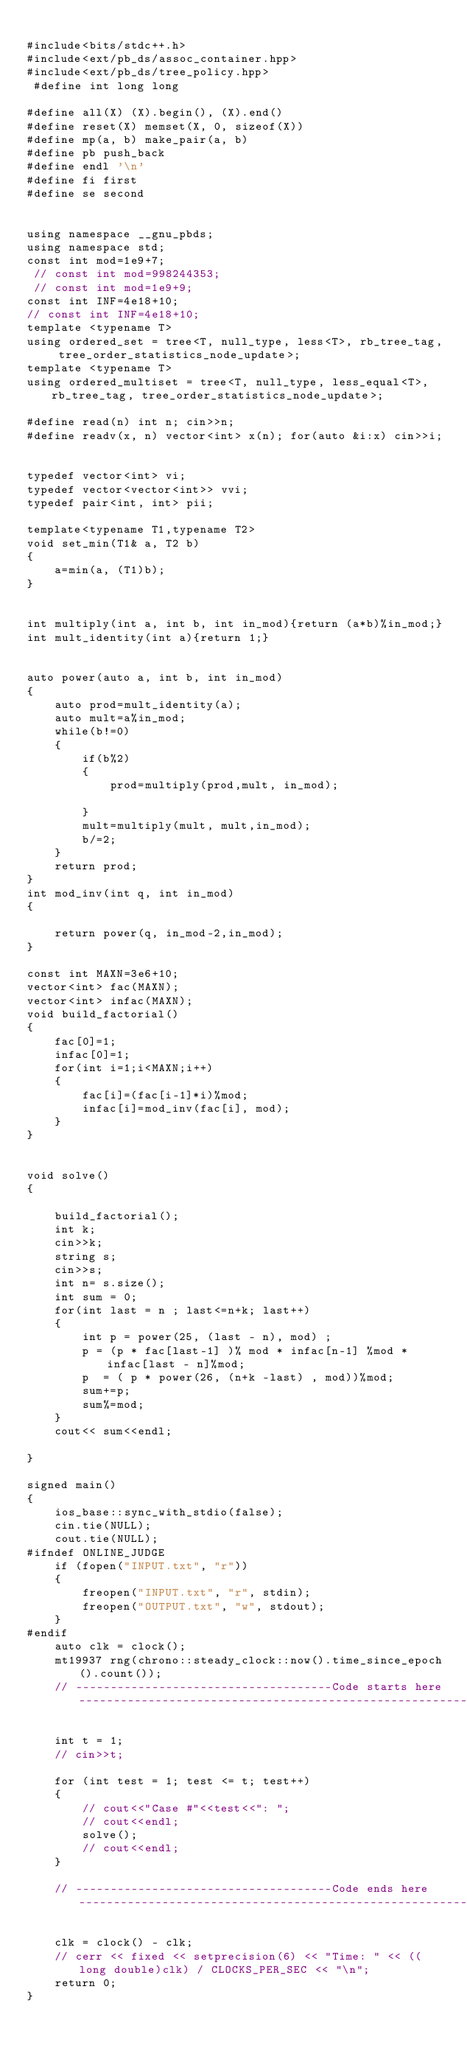Convert code to text. <code><loc_0><loc_0><loc_500><loc_500><_C++_>
#include<bits/stdc++.h>
#include<ext/pb_ds/assoc_container.hpp>
#include<ext/pb_ds/tree_policy.hpp>
 #define int long long

#define all(X) (X).begin(), (X).end()
#define reset(X) memset(X, 0, sizeof(X))
#define mp(a, b) make_pair(a, b)
#define pb push_back
#define endl '\n'
#define fi first
#define se second


using namespace __gnu_pbds;
using namespace std;
const int mod=1e9+7;
 // const int mod=998244353;
 // const int mod=1e9+9;
const int INF=4e18+10;
// const int INF=4e18+10;
template <typename T>
using ordered_set = tree<T, null_type, less<T>, rb_tree_tag, tree_order_statistics_node_update>;
template <typename T>
using ordered_multiset = tree<T, null_type, less_equal<T>, rb_tree_tag, tree_order_statistics_node_update>;

#define read(n) int n; cin>>n;
#define readv(x, n) vector<int> x(n); for(auto &i:x) cin>>i;


typedef vector<int> vi;
typedef vector<vector<int>> vvi;
typedef pair<int, int> pii;

template<typename T1,typename T2>
void set_min(T1& a, T2 b)
{
    a=min(a, (T1)b);
}


int multiply(int a, int b, int in_mod){return (a*b)%in_mod;}
int mult_identity(int a){return 1;}


auto power(auto a, int b, int in_mod)
{
    auto prod=mult_identity(a);
    auto mult=a%in_mod;
    while(b!=0)
    {
        if(b%2)
        {
            prod=multiply(prod,mult, in_mod);

        }
        mult=multiply(mult, mult,in_mod);
        b/=2;
    }
    return prod;
}
int mod_inv(int q, int in_mod)
{

    return power(q, in_mod-2,in_mod);
}

const int MAXN=3e6+10;
vector<int> fac(MAXN);
vector<int> infac(MAXN);
void build_factorial()
{
    fac[0]=1;
    infac[0]=1;
    for(int i=1;i<MAXN;i++)
    {
        fac[i]=(fac[i-1]*i)%mod;
        infac[i]=mod_inv(fac[i], mod);
    }
}


void solve()
{

    build_factorial();
    int k;
    cin>>k;
    string s;
    cin>>s;
    int n= s.size();
    int sum = 0;
    for(int last = n ; last<=n+k; last++)
    {
        int p = power(25, (last - n), mod) ;
        p = (p * fac[last-1] )% mod * infac[n-1] %mod * infac[last - n]%mod;
        p  = ( p * power(26, (n+k -last) , mod))%mod;
        sum+=p;
        sum%=mod;
    }
    cout<< sum<<endl;

}

signed main()
{
    ios_base::sync_with_stdio(false);
    cin.tie(NULL);
    cout.tie(NULL);
#ifndef ONLINE_JUDGE
    if (fopen("INPUT.txt", "r"))
    {
        freopen("INPUT.txt", "r", stdin);
        freopen("OUTPUT.txt", "w", stdout);
    }
#endif
    auto clk = clock();
    mt19937 rng(chrono::steady_clock::now().time_since_epoch().count());
    // -------------------------------------Code starts here---------------------------------------------------------------------

    int t = 1;
    // cin>>t;

    for (int test = 1; test <= t; test++)
    {
        // cout<<"Case #"<<test<<": ";
        // cout<<endl;
        solve();
        // cout<<endl;
    }

    // -------------------------------------Code ends here------------------------------------------------------------------

    clk = clock() - clk;
    // cerr << fixed << setprecision(6) << "Time: " << ((long double)clk) / CLOCKS_PER_SEC << "\n";
    return 0;
}
</code> 